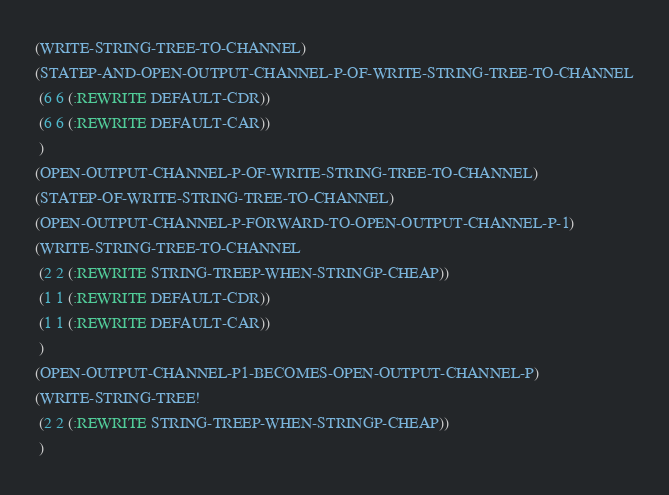Convert code to text. <code><loc_0><loc_0><loc_500><loc_500><_Lisp_>(WRITE-STRING-TREE-TO-CHANNEL)
(STATEP-AND-OPEN-OUTPUT-CHANNEL-P-OF-WRITE-STRING-TREE-TO-CHANNEL
 (6 6 (:REWRITE DEFAULT-CDR))
 (6 6 (:REWRITE DEFAULT-CAR))
 )
(OPEN-OUTPUT-CHANNEL-P-OF-WRITE-STRING-TREE-TO-CHANNEL)
(STATEP-OF-WRITE-STRING-TREE-TO-CHANNEL)
(OPEN-OUTPUT-CHANNEL-P-FORWARD-TO-OPEN-OUTPUT-CHANNEL-P-1)
(WRITE-STRING-TREE-TO-CHANNEL
 (2 2 (:REWRITE STRING-TREEP-WHEN-STRINGP-CHEAP))
 (1 1 (:REWRITE DEFAULT-CDR))
 (1 1 (:REWRITE DEFAULT-CAR))
 )
(OPEN-OUTPUT-CHANNEL-P1-BECOMES-OPEN-OUTPUT-CHANNEL-P)
(WRITE-STRING-TREE!
 (2 2 (:REWRITE STRING-TREEP-WHEN-STRINGP-CHEAP))
 )
</code> 